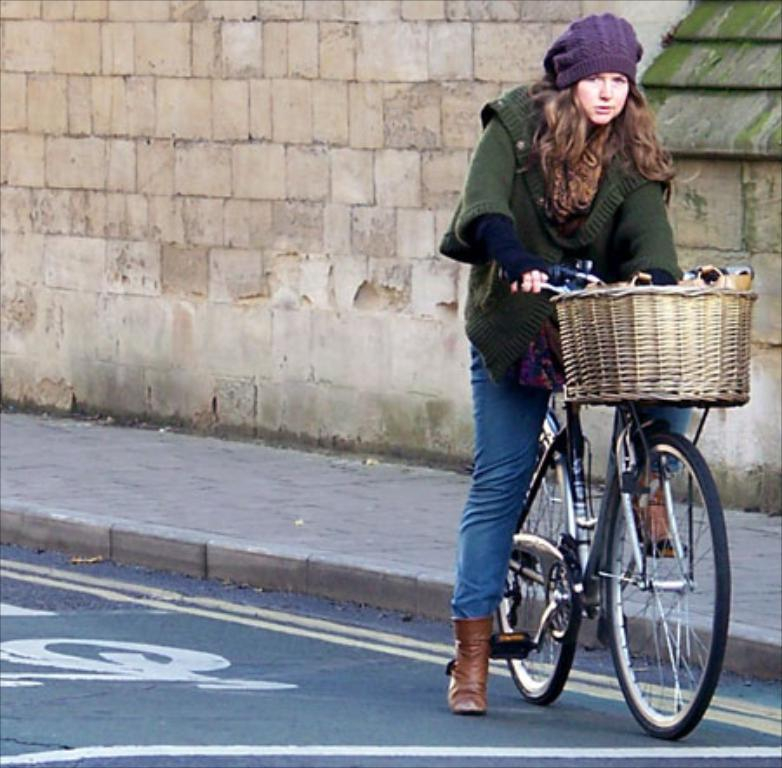Who is the main subject in the image? There is a woman in the image. What is the woman doing in the image? The woman is sitting on a bicycle. What is attached to the front of the bicycle? There is a basket in front of the bicycle. What is the woman wearing on her upper body? The woman is wearing a green jacket. What is the woman wearing on her head? The woman is wearing a purple cap. What type of coast can be seen in the background of the image? There is no coast visible in the image; it features a woman sitting on a bicycle. Is there a baby present in the image? No, there is no baby present in the image; it features a woman sitting on a bicycle. 